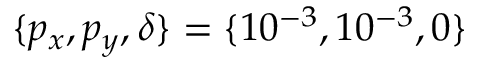Convert formula to latex. <formula><loc_0><loc_0><loc_500><loc_500>\{ p _ { x } , p _ { y } , \delta \} = \{ 1 0 ^ { - 3 } , 1 0 ^ { - 3 } , 0 \}</formula> 